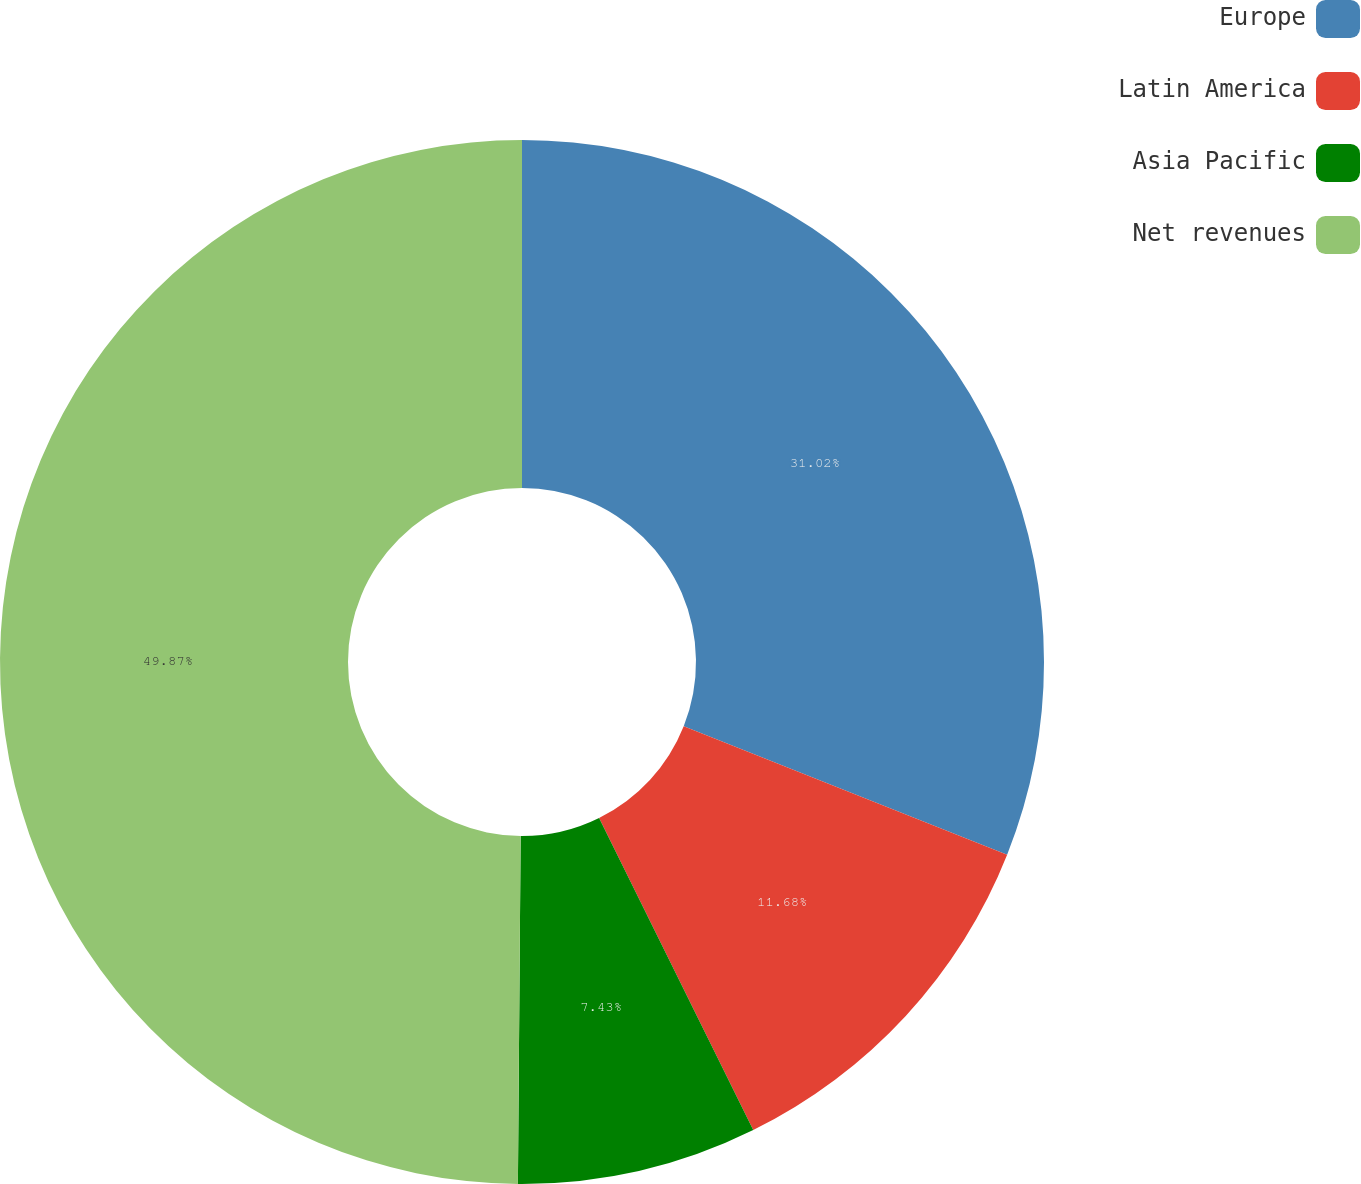Convert chart to OTSL. <chart><loc_0><loc_0><loc_500><loc_500><pie_chart><fcel>Europe<fcel>Latin America<fcel>Asia Pacific<fcel>Net revenues<nl><fcel>31.02%<fcel>11.68%<fcel>7.43%<fcel>49.88%<nl></chart> 